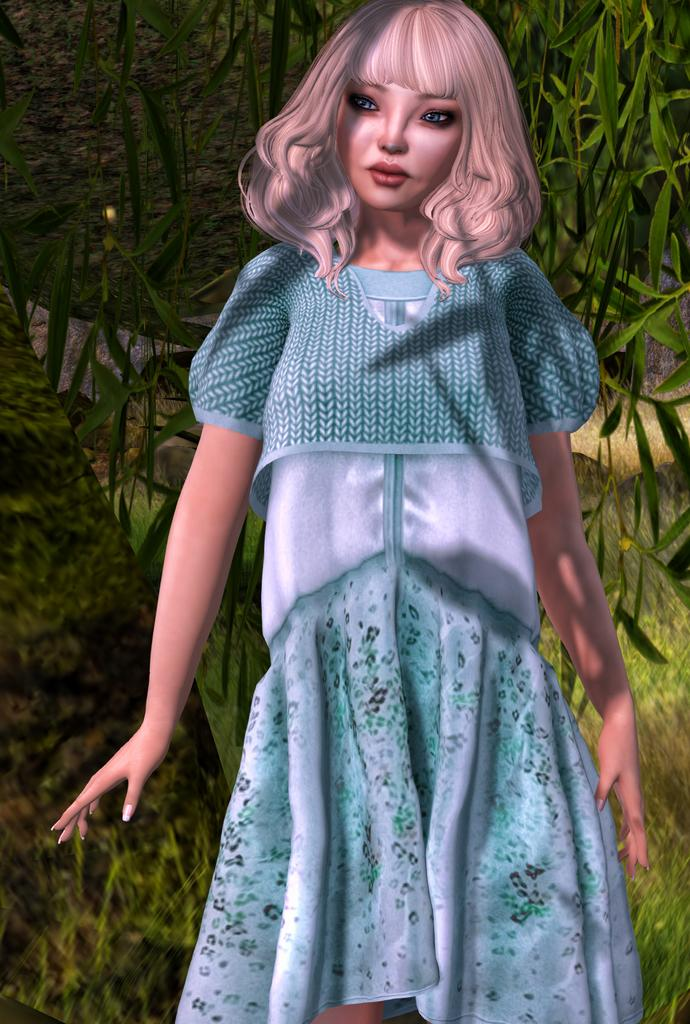Who is the main subject in the foreground of the image? There is a woman in the foreground of the image. What is the woman doing in the image? The woman is standing. What type of natural environment can be seen in the background of the image? There are plants and grass in the background of the image. What type of boot is visible on the woman's foot in the image? There is no boot visible on the woman's foot in the image; she is not wearing any footwear. 